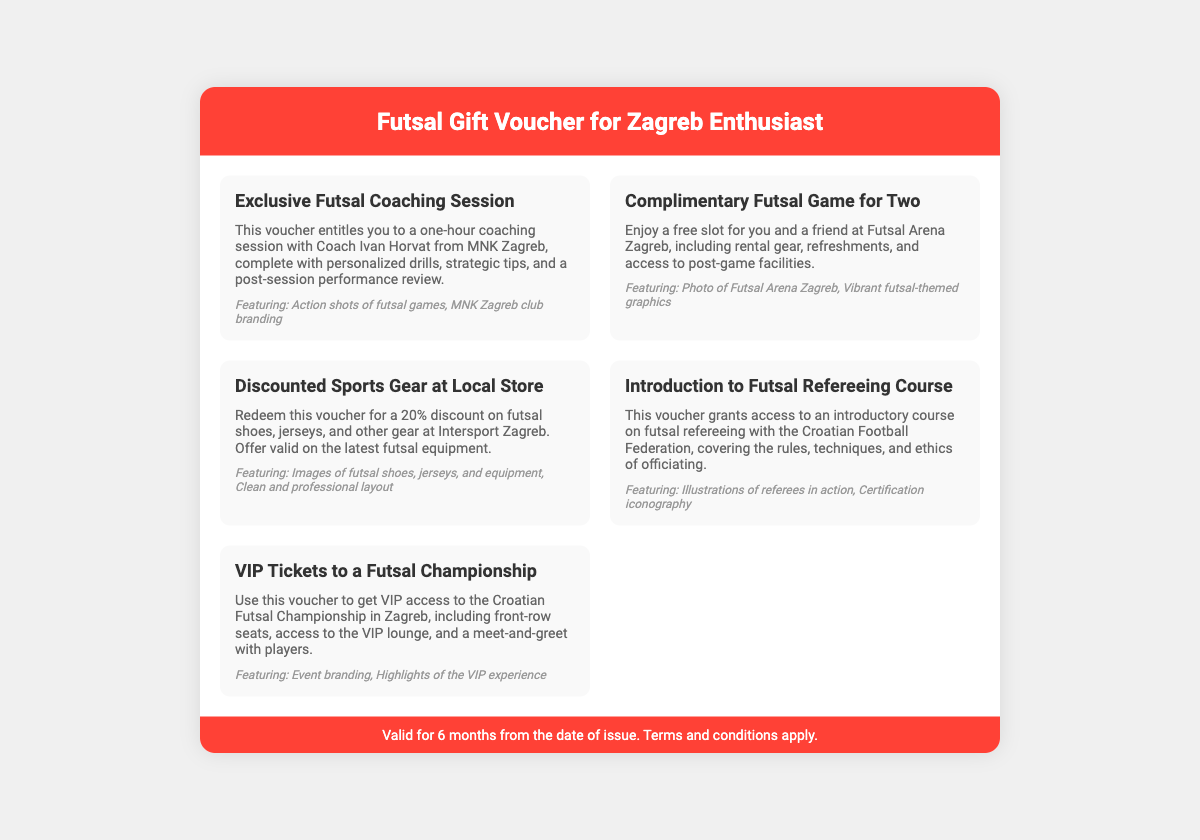What is the duration of the coaching session? The voucher states the coaching session lasts for one hour.
Answer: One hour Who is the coach mentioned in the coaching session? The document specifies Coach Ivan Horvat from MNK Zagreb.
Answer: Ivan Horvat What discount does the sports gear voucher provide? The document mentions a 20% discount on futsal gear at a local store.
Answer: 20% Which arena is associated with the complimentary game for two? The voucher refers to Futsal Arena Zagreb for the complimentary game.
Answer: Futsal Arena Zagreb What is included in the VIP ticket offer? The document lists front-row seats, access to the VIP lounge, and a meet-and-greet with players as part of the VIP experience.
Answer: VIP lounge What course does the refereeing voucher grant access to? The voucher provides access to an introductory course on futsal refereeing.
Answer: Refereeing course How long is the voucher valid for? The footer notes that the voucher is valid for 6 months from the date of issue.
Answer: 6 months What is featured in the design of the discounted sports gear voucher? The document notes the design features images of the latest futsal equipment.
Answer: Latest futsal equipment What are the design elements for the coaching session voucher? The design elements include action shots of futsal games and MNK Zagreb club branding.
Answer: Action shots, MNK Zagreb branding 